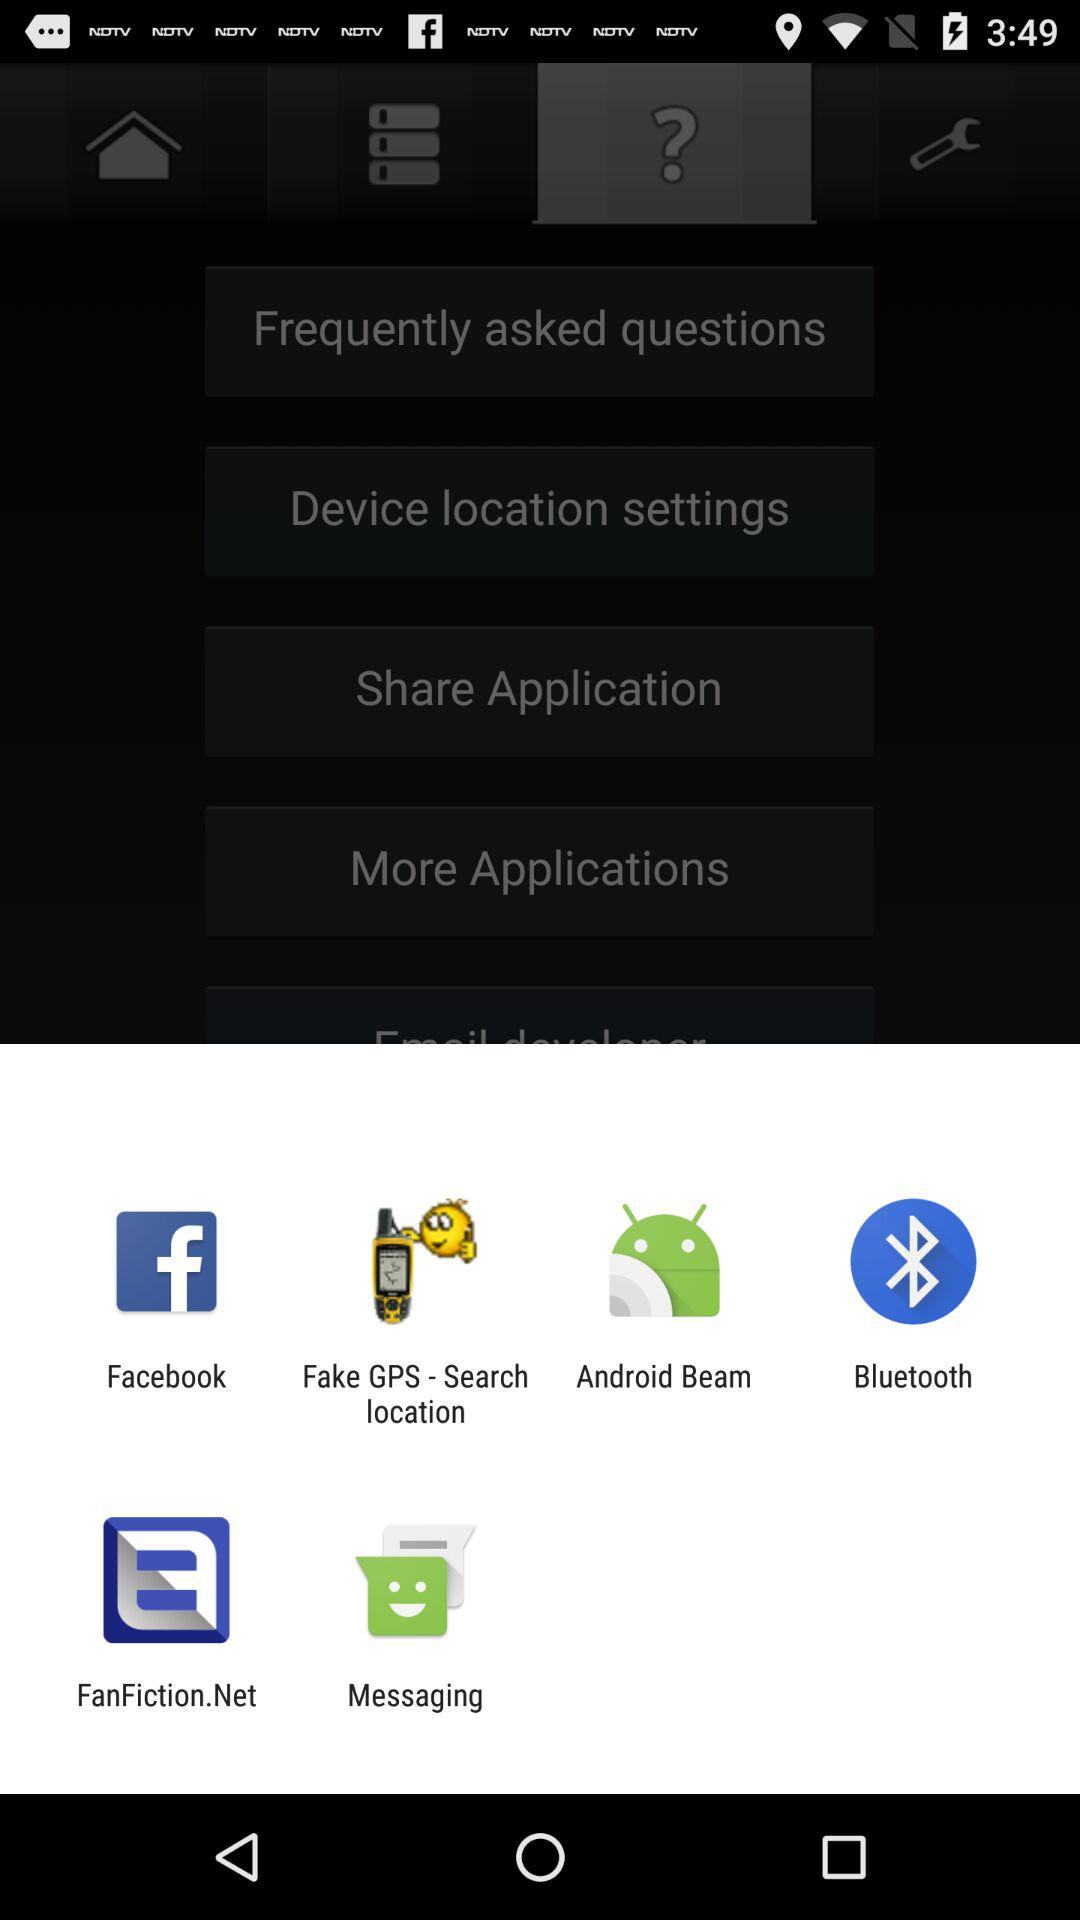Through which app can we share the content? You can share the content through "Facebook", "Fake GPS - Search location", "Android Beam", "Bluetooth", "FanFiction.Net" and "Messaging". 